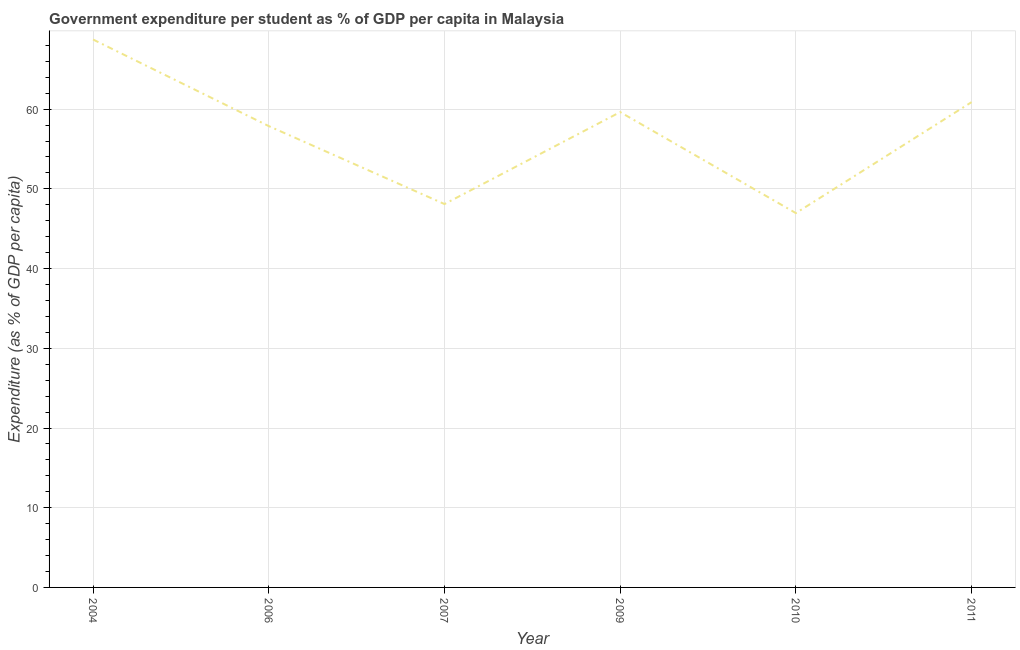What is the government expenditure per student in 2006?
Provide a succinct answer. 57.88. Across all years, what is the maximum government expenditure per student?
Offer a terse response. 68.74. Across all years, what is the minimum government expenditure per student?
Offer a terse response. 46.96. In which year was the government expenditure per student minimum?
Your response must be concise. 2010. What is the sum of the government expenditure per student?
Offer a terse response. 342.2. What is the difference between the government expenditure per student in 2004 and 2009?
Your answer should be compact. 9.11. What is the average government expenditure per student per year?
Ensure brevity in your answer.  57.03. What is the median government expenditure per student?
Offer a terse response. 58.76. In how many years, is the government expenditure per student greater than 60 %?
Give a very brief answer. 2. Do a majority of the years between 2009 and 2011 (inclusive) have government expenditure per student greater than 52 %?
Your answer should be very brief. Yes. What is the ratio of the government expenditure per student in 2006 to that in 2007?
Provide a succinct answer. 1.2. Is the difference between the government expenditure per student in 2006 and 2011 greater than the difference between any two years?
Give a very brief answer. No. What is the difference between the highest and the second highest government expenditure per student?
Ensure brevity in your answer.  7.86. What is the difference between the highest and the lowest government expenditure per student?
Offer a very short reply. 21.78. In how many years, is the government expenditure per student greater than the average government expenditure per student taken over all years?
Your response must be concise. 4. How many years are there in the graph?
Give a very brief answer. 6. What is the difference between two consecutive major ticks on the Y-axis?
Your response must be concise. 10. Does the graph contain grids?
Offer a terse response. Yes. What is the title of the graph?
Give a very brief answer. Government expenditure per student as % of GDP per capita in Malaysia. What is the label or title of the X-axis?
Keep it short and to the point. Year. What is the label or title of the Y-axis?
Make the answer very short. Expenditure (as % of GDP per capita). What is the Expenditure (as % of GDP per capita) of 2004?
Provide a succinct answer. 68.74. What is the Expenditure (as % of GDP per capita) in 2006?
Offer a very short reply. 57.88. What is the Expenditure (as % of GDP per capita) in 2007?
Your answer should be very brief. 48.1. What is the Expenditure (as % of GDP per capita) of 2009?
Your answer should be very brief. 59.63. What is the Expenditure (as % of GDP per capita) of 2010?
Provide a succinct answer. 46.96. What is the Expenditure (as % of GDP per capita) of 2011?
Your answer should be very brief. 60.88. What is the difference between the Expenditure (as % of GDP per capita) in 2004 and 2006?
Ensure brevity in your answer.  10.86. What is the difference between the Expenditure (as % of GDP per capita) in 2004 and 2007?
Make the answer very short. 20.64. What is the difference between the Expenditure (as % of GDP per capita) in 2004 and 2009?
Ensure brevity in your answer.  9.11. What is the difference between the Expenditure (as % of GDP per capita) in 2004 and 2010?
Make the answer very short. 21.78. What is the difference between the Expenditure (as % of GDP per capita) in 2004 and 2011?
Give a very brief answer. 7.86. What is the difference between the Expenditure (as % of GDP per capita) in 2006 and 2007?
Offer a terse response. 9.78. What is the difference between the Expenditure (as % of GDP per capita) in 2006 and 2009?
Ensure brevity in your answer.  -1.76. What is the difference between the Expenditure (as % of GDP per capita) in 2006 and 2010?
Make the answer very short. 10.92. What is the difference between the Expenditure (as % of GDP per capita) in 2006 and 2011?
Provide a short and direct response. -3. What is the difference between the Expenditure (as % of GDP per capita) in 2007 and 2009?
Provide a short and direct response. -11.54. What is the difference between the Expenditure (as % of GDP per capita) in 2007 and 2010?
Provide a succinct answer. 1.13. What is the difference between the Expenditure (as % of GDP per capita) in 2007 and 2011?
Make the answer very short. -12.78. What is the difference between the Expenditure (as % of GDP per capita) in 2009 and 2010?
Give a very brief answer. 12.67. What is the difference between the Expenditure (as % of GDP per capita) in 2009 and 2011?
Keep it short and to the point. -1.25. What is the difference between the Expenditure (as % of GDP per capita) in 2010 and 2011?
Keep it short and to the point. -13.92. What is the ratio of the Expenditure (as % of GDP per capita) in 2004 to that in 2006?
Make the answer very short. 1.19. What is the ratio of the Expenditure (as % of GDP per capita) in 2004 to that in 2007?
Offer a terse response. 1.43. What is the ratio of the Expenditure (as % of GDP per capita) in 2004 to that in 2009?
Your response must be concise. 1.15. What is the ratio of the Expenditure (as % of GDP per capita) in 2004 to that in 2010?
Provide a short and direct response. 1.46. What is the ratio of the Expenditure (as % of GDP per capita) in 2004 to that in 2011?
Provide a succinct answer. 1.13. What is the ratio of the Expenditure (as % of GDP per capita) in 2006 to that in 2007?
Your answer should be very brief. 1.2. What is the ratio of the Expenditure (as % of GDP per capita) in 2006 to that in 2009?
Your answer should be very brief. 0.97. What is the ratio of the Expenditure (as % of GDP per capita) in 2006 to that in 2010?
Ensure brevity in your answer.  1.23. What is the ratio of the Expenditure (as % of GDP per capita) in 2006 to that in 2011?
Offer a terse response. 0.95. What is the ratio of the Expenditure (as % of GDP per capita) in 2007 to that in 2009?
Ensure brevity in your answer.  0.81. What is the ratio of the Expenditure (as % of GDP per capita) in 2007 to that in 2011?
Ensure brevity in your answer.  0.79. What is the ratio of the Expenditure (as % of GDP per capita) in 2009 to that in 2010?
Give a very brief answer. 1.27. What is the ratio of the Expenditure (as % of GDP per capita) in 2010 to that in 2011?
Give a very brief answer. 0.77. 